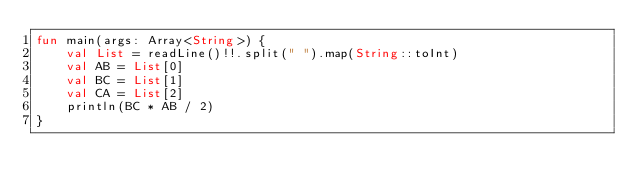<code> <loc_0><loc_0><loc_500><loc_500><_Kotlin_>fun main(args: Array<String>) {
    val List = readLine()!!.split(" ").map(String::toInt)
    val AB = List[0]
    val BC = List[1]
    val CA = List[2]
    println(BC * AB / 2)
}</code> 